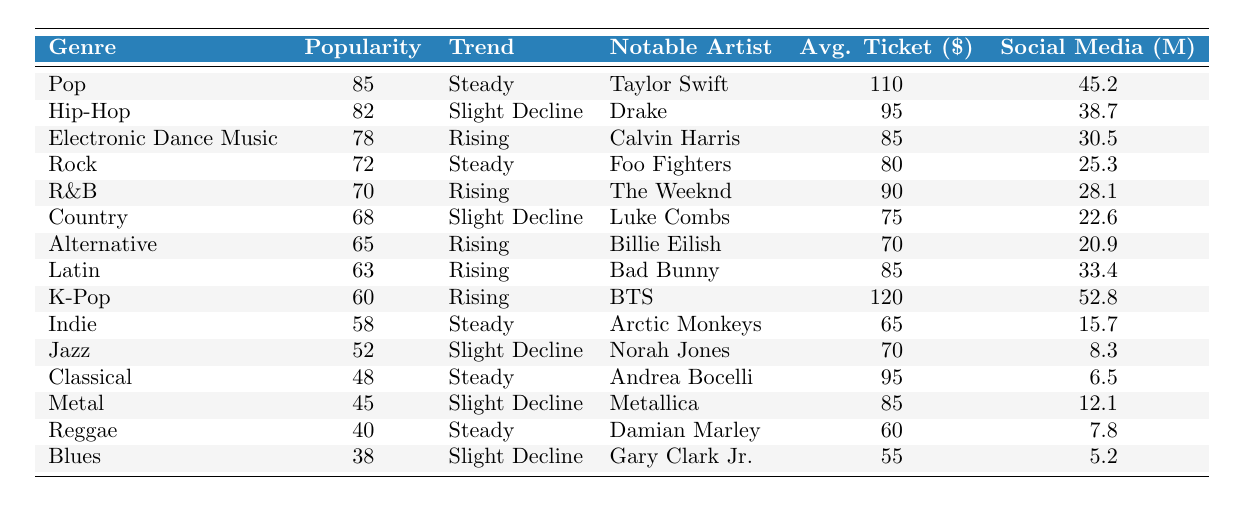What is the popularity score of the Pop genre? The table lists the popularity score for the Pop genre, which is clearly stated as 85.
Answer: 85 Which genre has the highest average ticket price? By examining the Average Ticket Price column, K-Pop has the highest ticket price listed at $120.
Answer: K-Pop Is there a genre experiencing a rising trend? The Trend Direction column indicates that Electronic Dance Music, R&B, Alternative, Latin, and K-Pop are all tagged with a "Rising" trend.
Answer: Yes What is the average ticket price for Hip-Hop? The table specifies that the average ticket price for Hip-Hop is $95.
Answer: $95 Which notable artist represents the Rock genre? By looking at the Notable Artist column, we see that Foo Fighters is associated with the Rock genre.
Answer: Foo Fighters How many genres are experiencing a slight decline? Checking the Trend Direction column, there are three genres labeled as experiencing a "Slight Decline": Hip-Hop, Country, and Metal.
Answer: 3 What is the difference in popularity scores between Pop and Blues? The popularity score for Pop is 85 and for Blues it is 38. Subtracting these gives 85 - 38 = 47.
Answer: 47 Which genre has the lowest social media mentions? The Blues genre has the lowest social media mentions, listed at 5.2 million in the corresponding column.
Answer: Blues Identify a genre that has a steady trend direction and provides the average ticket price. Looking at the Trend Direction column, Pop, Rock, Indie, Classical, and Reggae are steady, with their respective average ticket prices being $110, $80, $65, $95, and $60.
Answer: Pop at $110 Which genre has a notable artist with the same initial as 'D'? Reviewing the Notable Artist column, Damian Marley (Reggae) starts with 'D', which is true, while Drake (Hip-Hop) also fits.
Answer: Reggae and Hip-Hop What is the total average ticket price of genres showing a rising trend? The average ticket prices for the rising genres (EDM, R&B, Alternative, Latin, K-Pop) are $85, $90, $70, $85, $120. Summing these gives $85 + $90 + $70 + $85 + $120 = $450. Dividing by 5 yields an average of $90.
Answer: $90 Is it true that Jazz genre has a higher popularity score than Reggae? Comparing the two, Jazz has a score of 52 while Reggae has 40, meaning Jazz is indeed higher.
Answer: Yes How does the average ticket price of K-Pop compare to that of the R&B genre? The average ticket price for K-Pop is $120 and for R&B is $90. Thus, K-Pop's ticket price is higher by $120 - $90 = $30.
Answer: $30 Which genre has the same popularity score as the Classical genre? The Classical genre has a popularity score of 48, and checking the table reveals that the genre closest to it without duplication is not listed.
Answer: None 